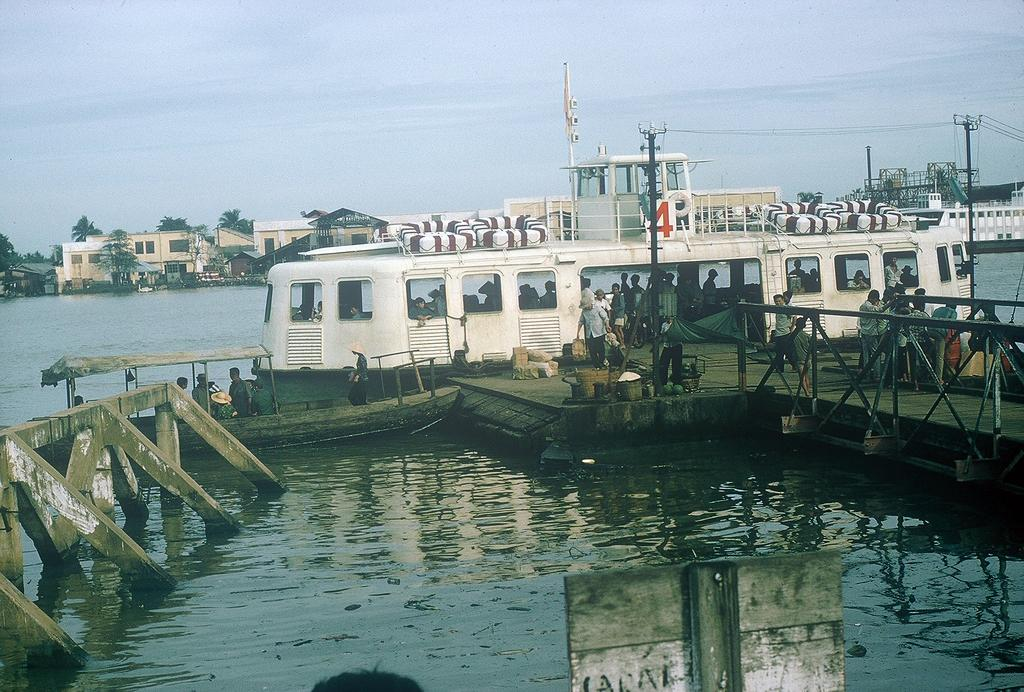What is at the bottom of the image? There is water at the bottom of the image. What can be seen floating on the water? There is a ship in the image. What type of structures are visible in the background? There are buildings in the background of the image. What type of vegetation is visible in the background? There are trees in the background of the image. What is visible at the top of the image? The sky is visible at the top of the image. Can you see a cord being used to tie up the trees in the image? There is no cord visible in the image, and the trees are not being tied up. What type of gardening tool is being used by the ship in the image? There is no gardening tool present in the image, as it features a ship on water with buildings and trees in the background. 